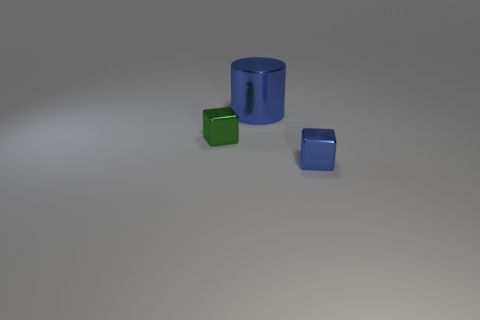How many other things are the same size as the green metallic thing?
Provide a short and direct response. 1. Are there more tiny spheres than large cylinders?
Offer a terse response. No. What number of shiny things are both in front of the blue shiny cylinder and left of the blue metal block?
Provide a short and direct response. 1. What is the shape of the blue object that is behind the small thing in front of the metal cube to the left of the big metallic cylinder?
Your answer should be very brief. Cylinder. Are there any other things that have the same shape as the small green object?
Provide a succinct answer. Yes. What number of cubes are red metal things or tiny blue objects?
Provide a succinct answer. 1. There is a small shiny thing that is right of the blue cylinder; does it have the same color as the big thing?
Keep it short and to the point. Yes. There is a blue thing behind the thing that is on the left side of the blue object behind the green metal object; what is its material?
Offer a terse response. Metal. Does the green metallic object have the same size as the blue cylinder?
Provide a succinct answer. No. There is a big shiny cylinder; is its color the same as the tiny metal block that is right of the large blue thing?
Offer a very short reply. Yes. 